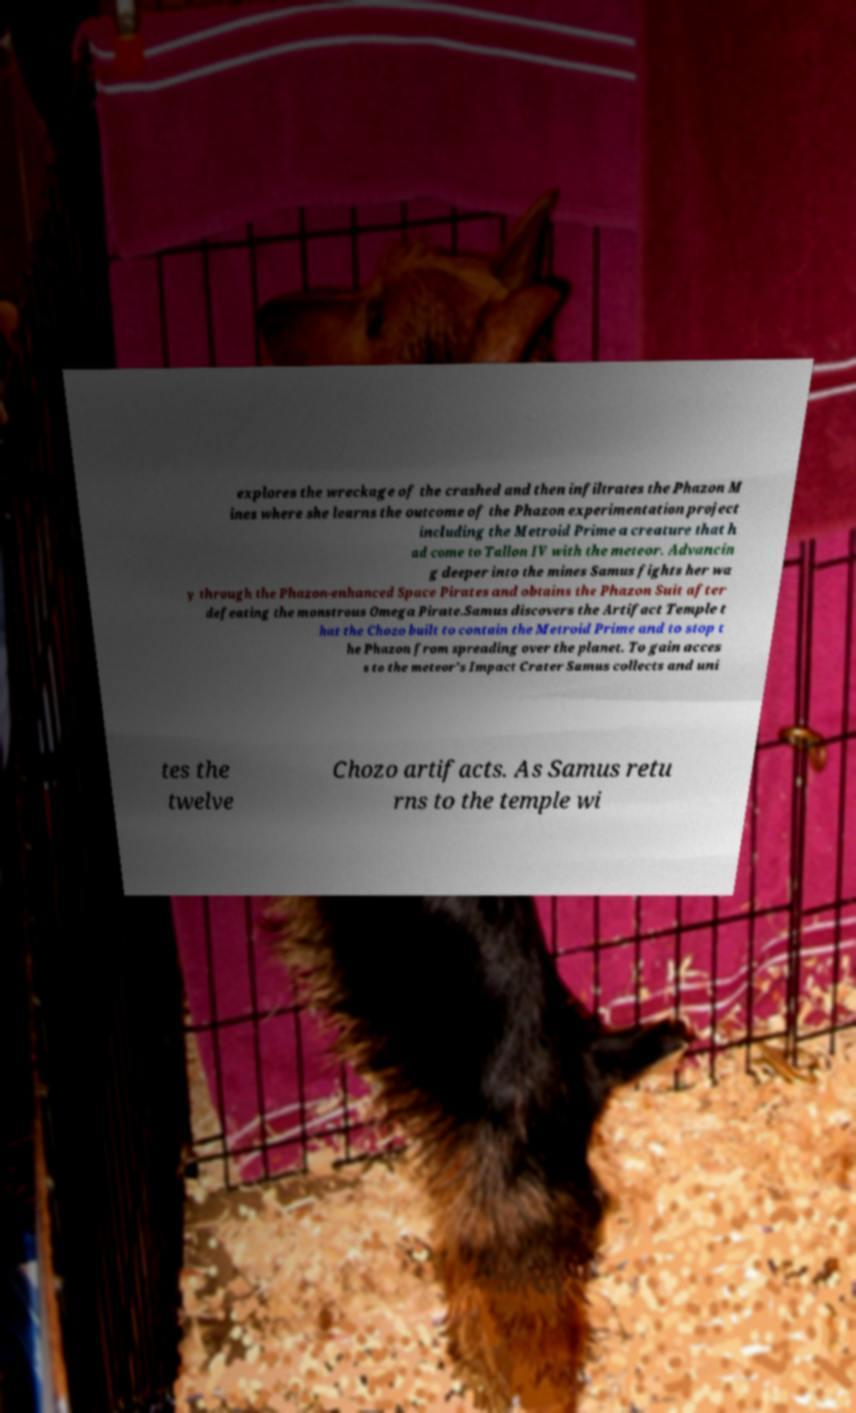Please read and relay the text visible in this image. What does it say? explores the wreckage of the crashed and then infiltrates the Phazon M ines where she learns the outcome of the Phazon experimentation project including the Metroid Prime a creature that h ad come to Tallon IV with the meteor. Advancin g deeper into the mines Samus fights her wa y through the Phazon-enhanced Space Pirates and obtains the Phazon Suit after defeating the monstrous Omega Pirate.Samus discovers the Artifact Temple t hat the Chozo built to contain the Metroid Prime and to stop t he Phazon from spreading over the planet. To gain acces s to the meteor's Impact Crater Samus collects and uni tes the twelve Chozo artifacts. As Samus retu rns to the temple wi 